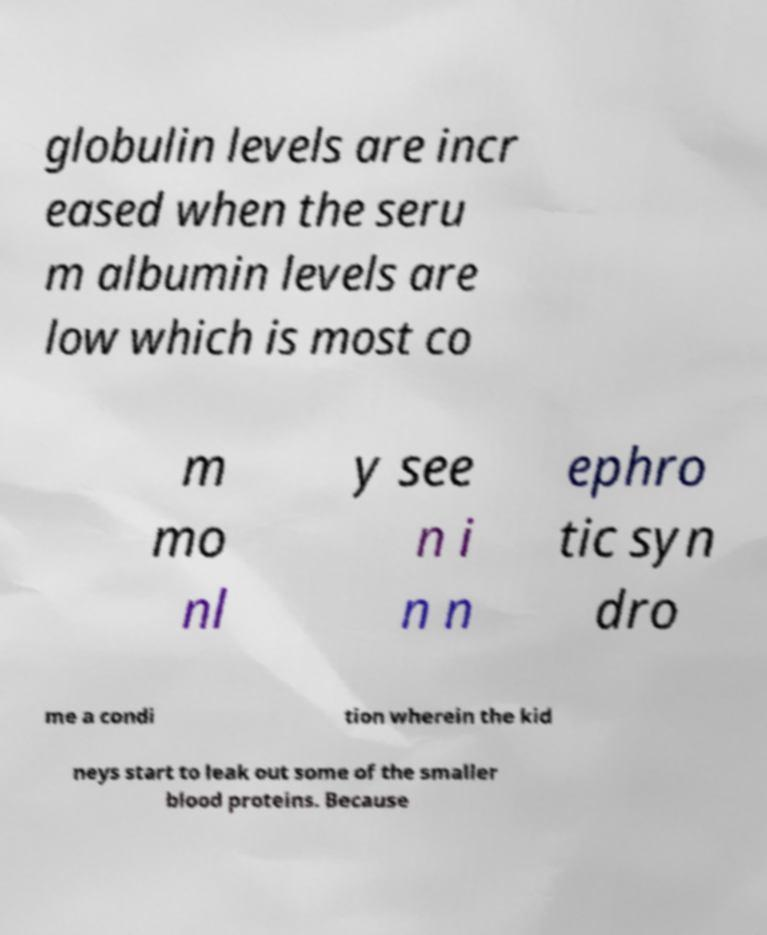Can you accurately transcribe the text from the provided image for me? globulin levels are incr eased when the seru m albumin levels are low which is most co m mo nl y see n i n n ephro tic syn dro me a condi tion wherein the kid neys start to leak out some of the smaller blood proteins. Because 